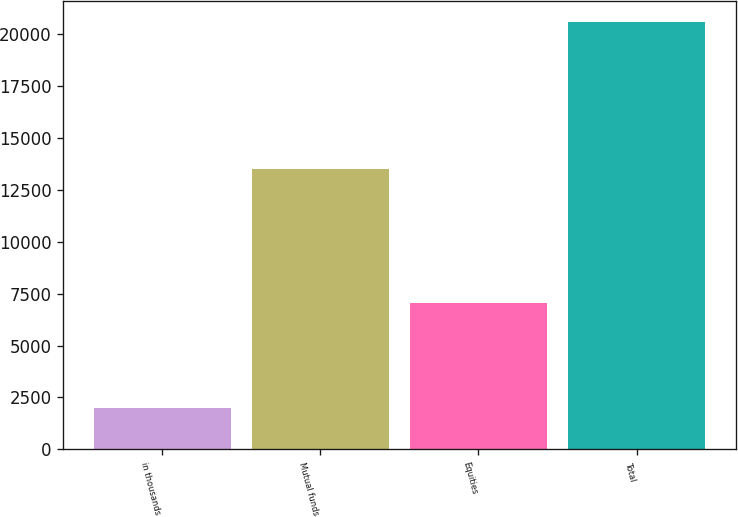Convert chart. <chart><loc_0><loc_0><loc_500><loc_500><bar_chart><fcel>in thousands<fcel>Mutual funds<fcel>Equities<fcel>Total<nl><fcel>2011<fcel>13536<fcel>7057<fcel>20593<nl></chart> 